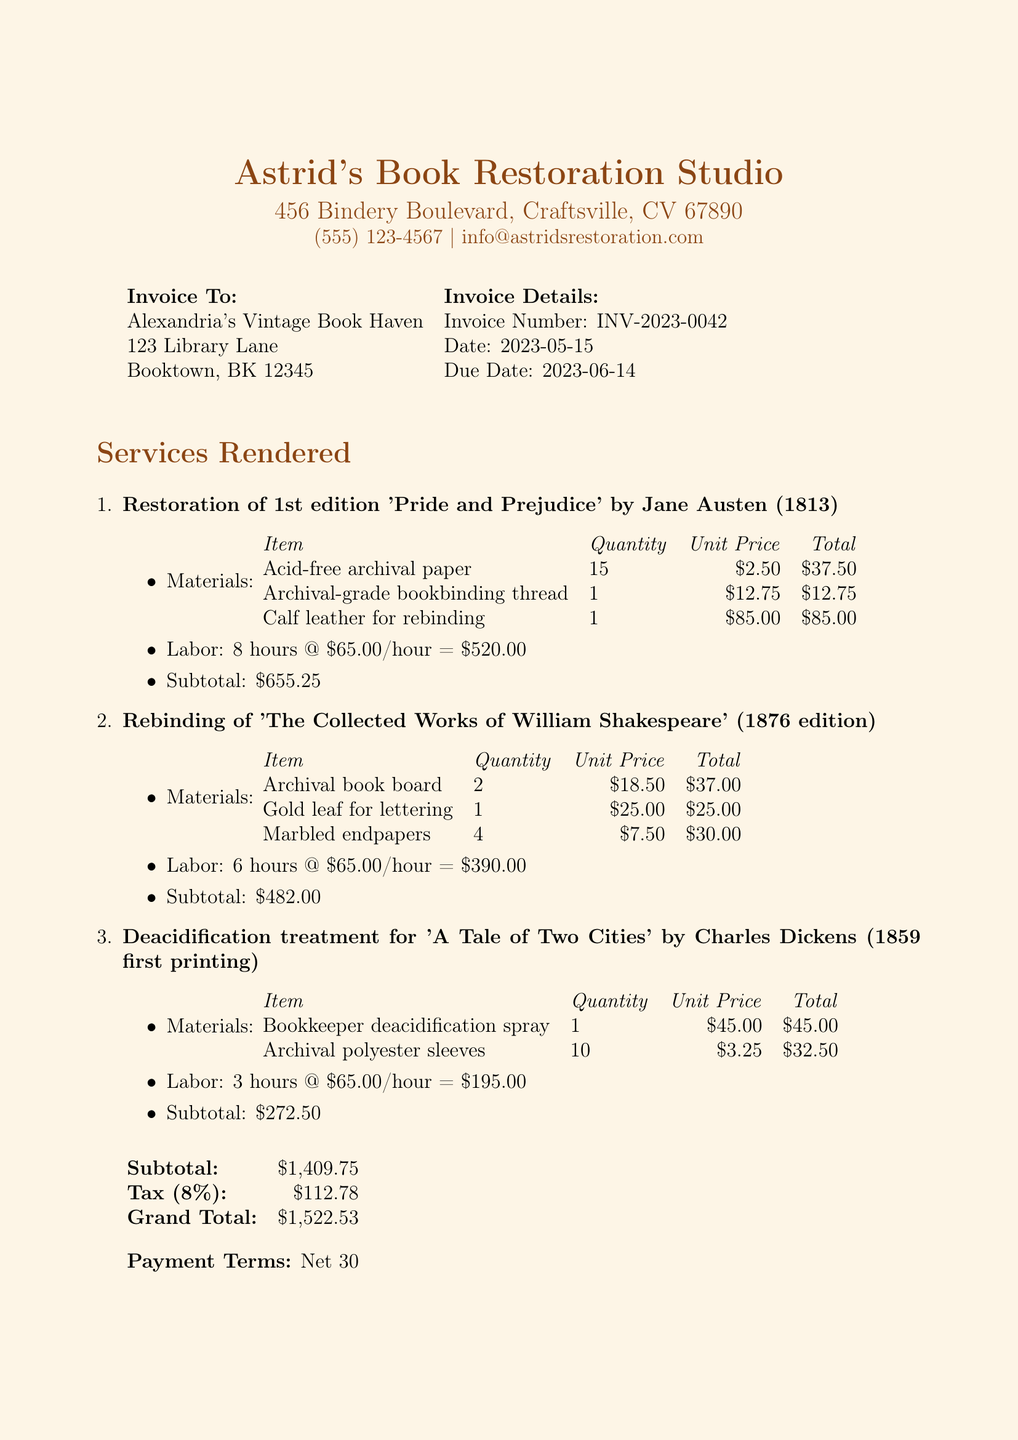What is the invoice number? The invoice number is listed in the invoice details section of the document.
Answer: INV-2023-0042 Who is the customer? The customer's name is stated in the invoice details section.
Answer: Alexandria's Vintage Book Haven What is the total amount due? The total amount due is calculated in the total section of the document.
Answer: 1522.53 How many hours of labor were used for the restoration of 'Pride and Prejudice'? The number of labor hours used is specified in the services rendered section for each item.
Answer: 8 What materials were used for the deacidification treatment? This question requires information from the materials list under the deacidification treatment item.
Answer: Bookkeeper deacidification spray, Archival polyester sleeves What is the tax rate applied to the invoice? The tax rate is noted in the total calculation section of the document.
Answer: 0.08 What is the payment term specified in the invoice? The payment terms are outlined at the end of the document.
Answer: Net 30 How many marbled endpapers were used for the rebinding of 'The Collected Works of William Shakespeare'? This requirement is specified in the materials section of the respective service rendered item.
Answer: 4 What is the subtotal for the rebinding of Shakespeare's works? The subtotal for this specific service is indicated in the services rendered section.
Answer: 482.00 